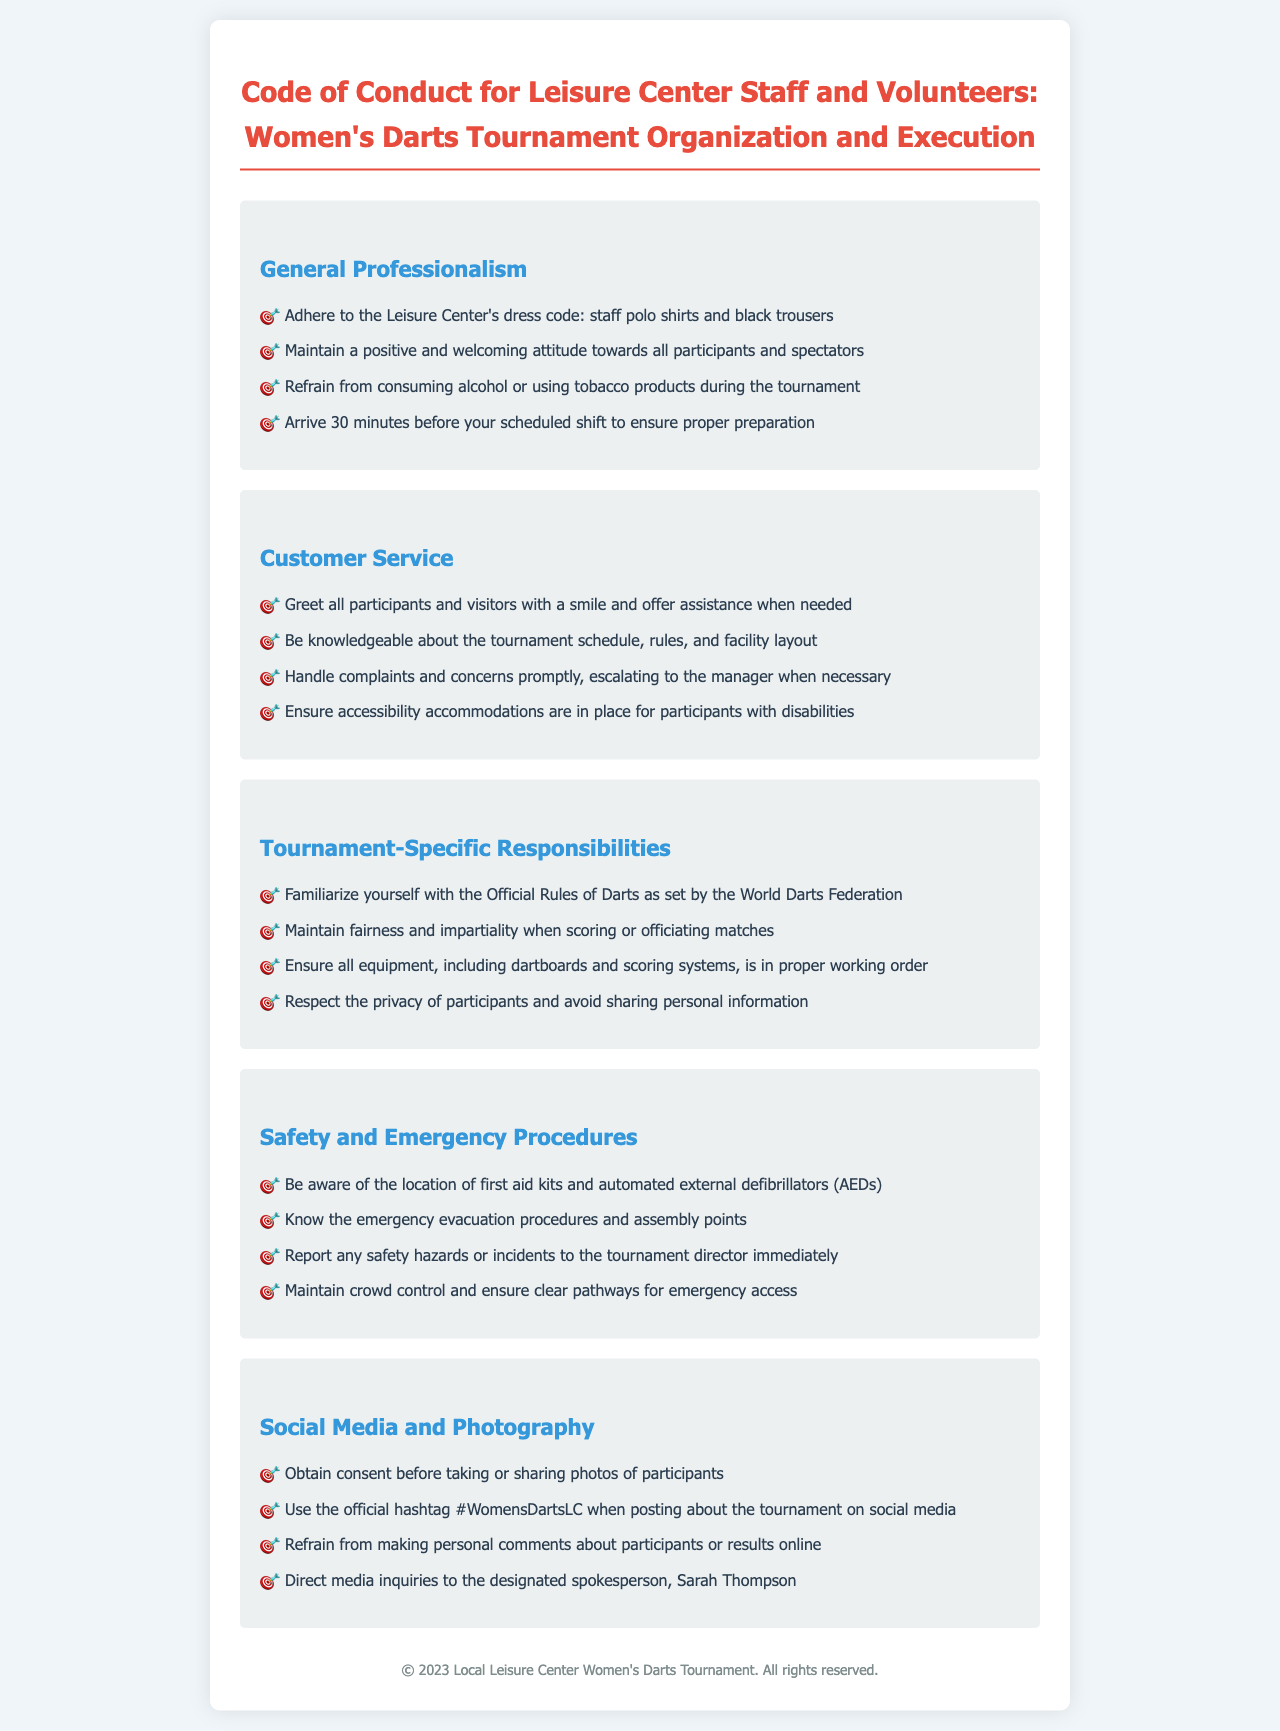what is the title of the document? The title of the document is clearly stated at the beginning, which is "Code of Conduct for Leisure Center Staff and Volunteers: Women's Darts Tournament Organization and Execution."
Answer: Code of Conduct for Leisure Center Staff and Volunteers: Women's Darts Tournament Organization and Execution what should staff wear according to the dress code? The dress code specifies that staff should wear polo shirts and black trousers as part of their formal attire during the tournament.
Answer: Staff polo shirts and black trousers how early should staff arrive before their shift? The document states that staff should arrive 30 minutes before their scheduled shift to ensure proper preparation.
Answer: 30 minutes who should media inquiries be directed to? The document designates Sarah Thompson as the spokesperson for media inquiries during the tournament.
Answer: Sarah Thompson which organization’s rules should staff familiarize themselves with? The document specifies that staff should familiarize themselves with the Official Rules of Darts as set by the World Darts Federation.
Answer: World Darts Federation why is it important to handle complaints promptly? The document indicates that handling complaints and concerns promptly is essential, ultimately leading to escalating matters to the manager when necessary to maintain professionalism.
Answer: Professionalism what is the official hashtag for the tournament on social media? The document mentions the official hashtag to be used when posting about the tournament on social media.
Answer: #WomensDartsLC what must staff ensure regarding accessibility accommodations? The document specifies that staff must ensure accessibility accommodations are in place for participants with disabilities, highlighting the importance of inclusivity.
Answer: Accessibility accommodations what is a key point about social media conduct? The document emphasizes the necessity of obtaining consent before taking or sharing photos of participants during the tournament as an important aspect of social media conduct.
Answer: Obtain consent 